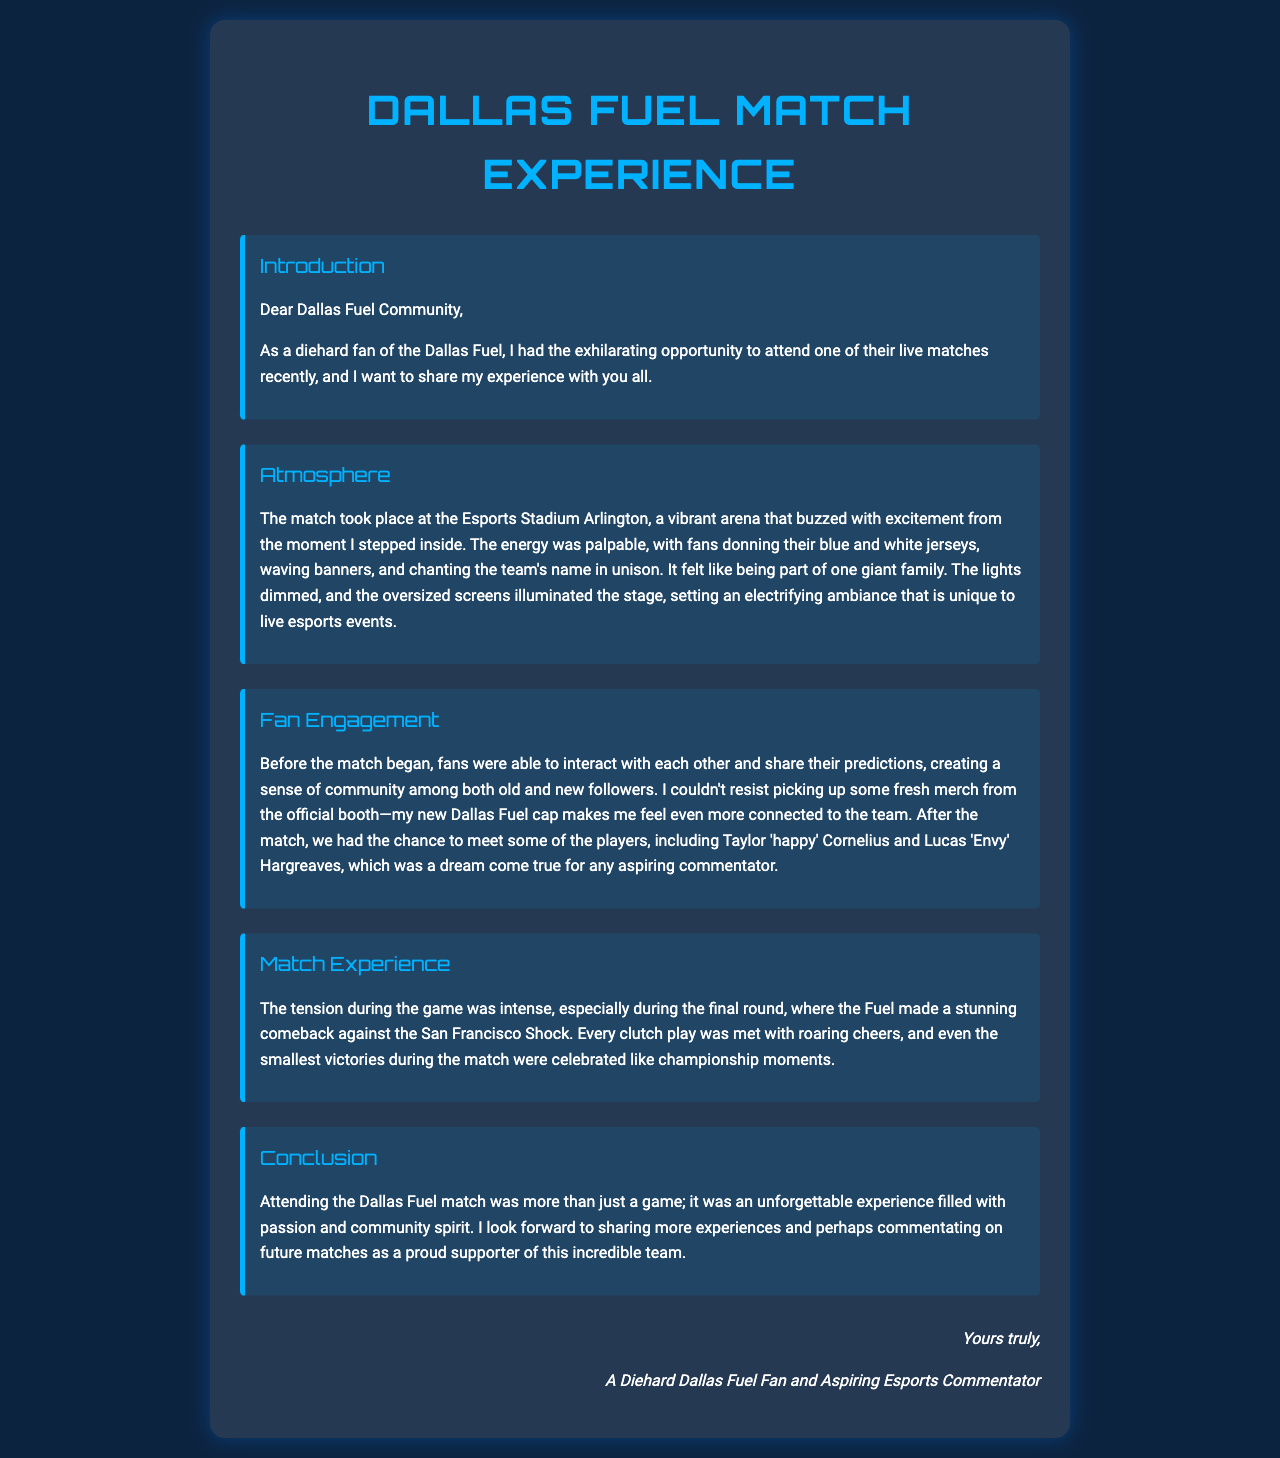What was the location of the match? The match took place at the Esports Stadium Arlington, which is mentioned in the atmosphere section.
Answer: Esports Stadium Arlington Who were two players mentioned in the fan engagement section? The letter specifically names Taylor 'happy' Cornelius and Lucas 'Envy' Hargreaves.
Answer: Taylor 'happy' Cornelius and Lucas 'Envy' Hargreaves What color jerseys did the fans wear? The fans wore blue and white jerseys, as noted in the atmosphere description.
Answer: Blue and white What type of experience is attending a Dallas Fuel match described as? The author describes it as an unforgettable experience filled with passion and community spirit in the conclusion.
Answer: Unforgettable experience What did the author purchase from the official booth? The author mentions picking up a Dallas Fuel cap, which illustrates fan engagement.
Answer: Dallas Fuel cap During which round did the Dallas Fuel make a comeback? The comeback occurred during the final round, as highlighted in the match experience section.
Answer: Final round How did fans react to every clutch play during the match? Fans responded to clutch plays with roaring cheers, emphasizing their engagement.
Answer: Roaring cheers What is the author's aspiration related to esports? The author expresses a desire to commentate on future matches, showcasing their enthusiasm for esports commentary.
Answer: Aspiring esports commentator 